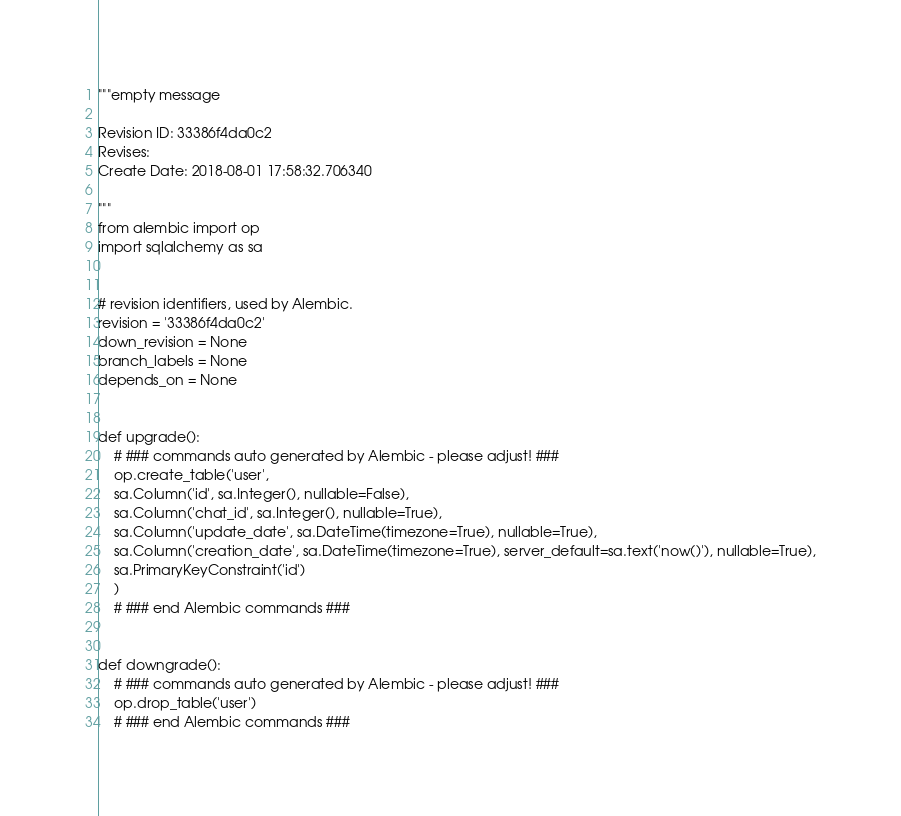Convert code to text. <code><loc_0><loc_0><loc_500><loc_500><_Python_>"""empty message

Revision ID: 33386f4da0c2
Revises: 
Create Date: 2018-08-01 17:58:32.706340

"""
from alembic import op
import sqlalchemy as sa


# revision identifiers, used by Alembic.
revision = '33386f4da0c2'
down_revision = None
branch_labels = None
depends_on = None


def upgrade():
    # ### commands auto generated by Alembic - please adjust! ###
    op.create_table('user',
    sa.Column('id', sa.Integer(), nullable=False),
    sa.Column('chat_id', sa.Integer(), nullable=True),
    sa.Column('update_date', sa.DateTime(timezone=True), nullable=True),
    sa.Column('creation_date', sa.DateTime(timezone=True), server_default=sa.text('now()'), nullable=True),
    sa.PrimaryKeyConstraint('id')
    )
    # ### end Alembic commands ###


def downgrade():
    # ### commands auto generated by Alembic - please adjust! ###
    op.drop_table('user')
    # ### end Alembic commands ###
</code> 